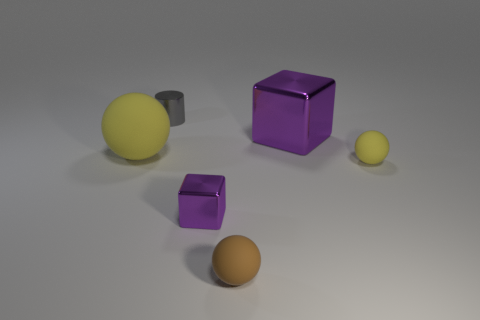Is there anything else that has the same shape as the tiny gray shiny object?
Keep it short and to the point. No. The thing in front of the purple shiny cube left of the small matte thing that is to the left of the tiny yellow thing is made of what material?
Ensure brevity in your answer.  Rubber. There is a thing that is the same color as the large ball; what is it made of?
Give a very brief answer. Rubber. What number of things are brown shiny balls or purple metallic cubes?
Make the answer very short. 2. Does the tiny thing that is on the right side of the large metallic cube have the same material as the brown object?
Your answer should be very brief. Yes. How many objects are either yellow rubber objects in front of the large yellow ball or large green objects?
Ensure brevity in your answer.  1. There is another tiny thing that is the same material as the tiny brown object; what is its color?
Your response must be concise. Yellow. Is there a yellow matte ball that has the same size as the gray metallic cylinder?
Provide a succinct answer. Yes. Is the color of the block on the right side of the tiny purple metallic thing the same as the small metallic cube?
Your answer should be compact. Yes. The thing that is both on the left side of the tiny metal cube and in front of the small gray cylinder is what color?
Ensure brevity in your answer.  Yellow. 